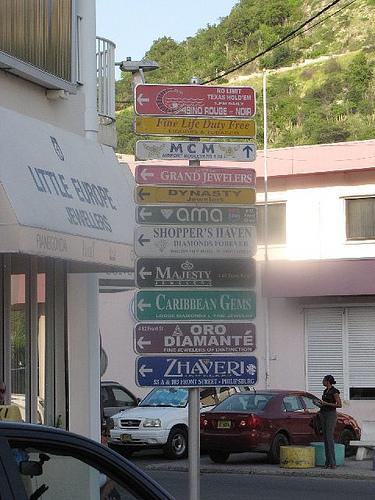How many signs are on this post?
Keep it brief. 11. What is being advertised on the red and black sign?
Answer briefly. Mahasti. What color is the sign for Caribbean Gems?
Write a very short answer. Green. Which way would you go if you wanted to look for gold and diamonds?
Short answer required. Left. 